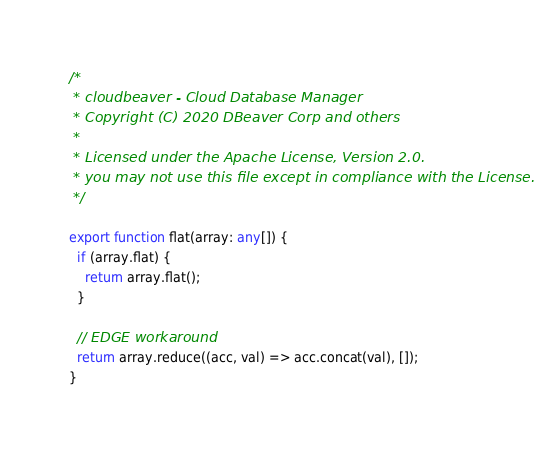<code> <loc_0><loc_0><loc_500><loc_500><_TypeScript_>/*
 * cloudbeaver - Cloud Database Manager
 * Copyright (C) 2020 DBeaver Corp and others
 *
 * Licensed under the Apache License, Version 2.0.
 * you may not use this file except in compliance with the License.
 */

export function flat(array: any[]) {
  if (array.flat) {
    return array.flat();
  }

  // EDGE workaround
  return array.reduce((acc, val) => acc.concat(val), []);
}
</code> 